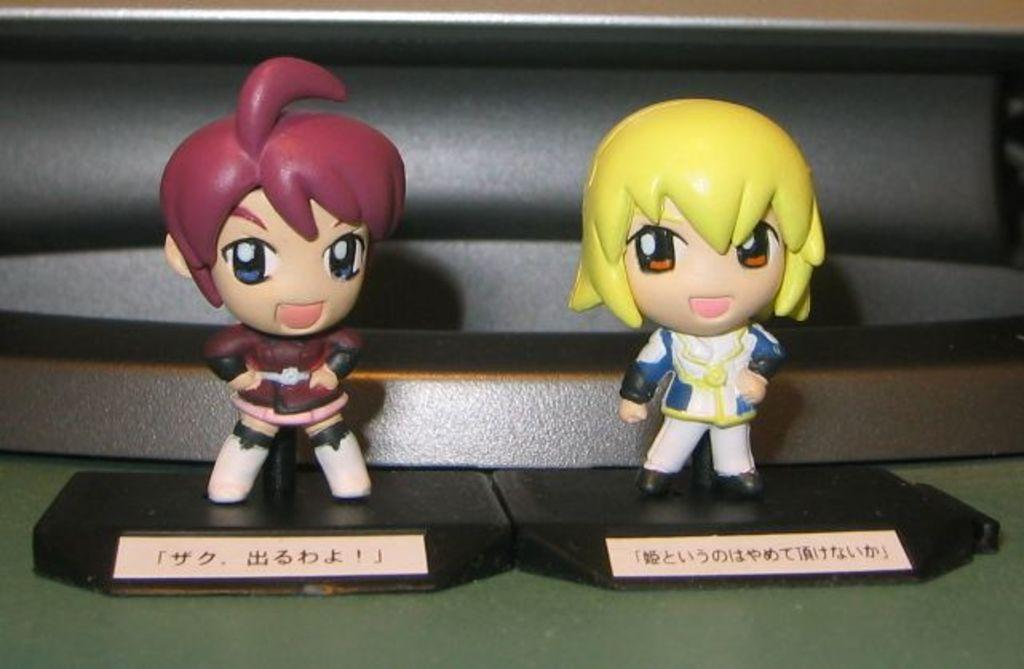How many toys can be seen in the image? There are two toys in the image. What else is present in the image besides the toys? There are cards with text in the image. Can you describe the object behind the toys? Unfortunately, the facts provided do not give any information about the object behind the toys. What type of waste can be seen in the image? There is no waste present in the image. How are the toys being transported in the image? The toys are not being transported in the image; they are stationary. 